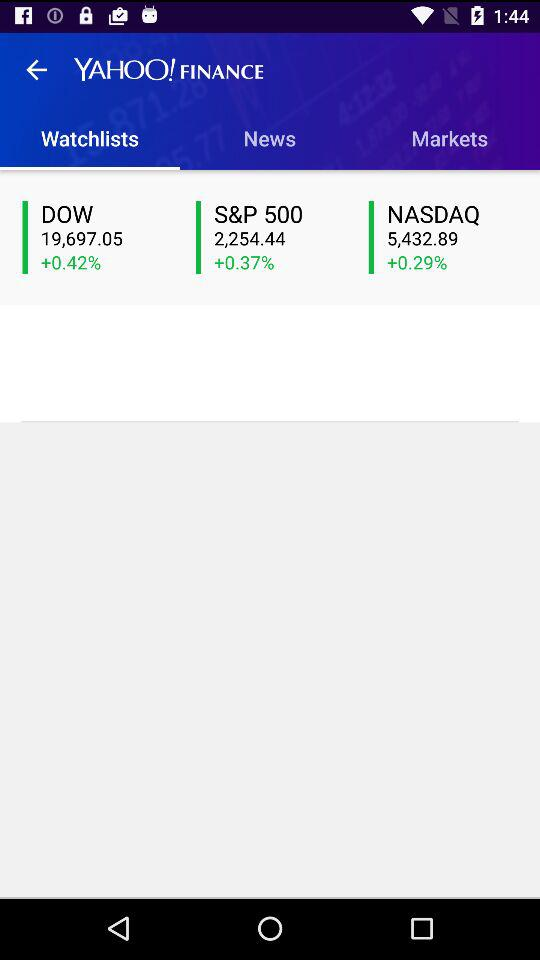How much is the S&P 500 up by?
Answer the question using a single word or phrase. +0.37% 